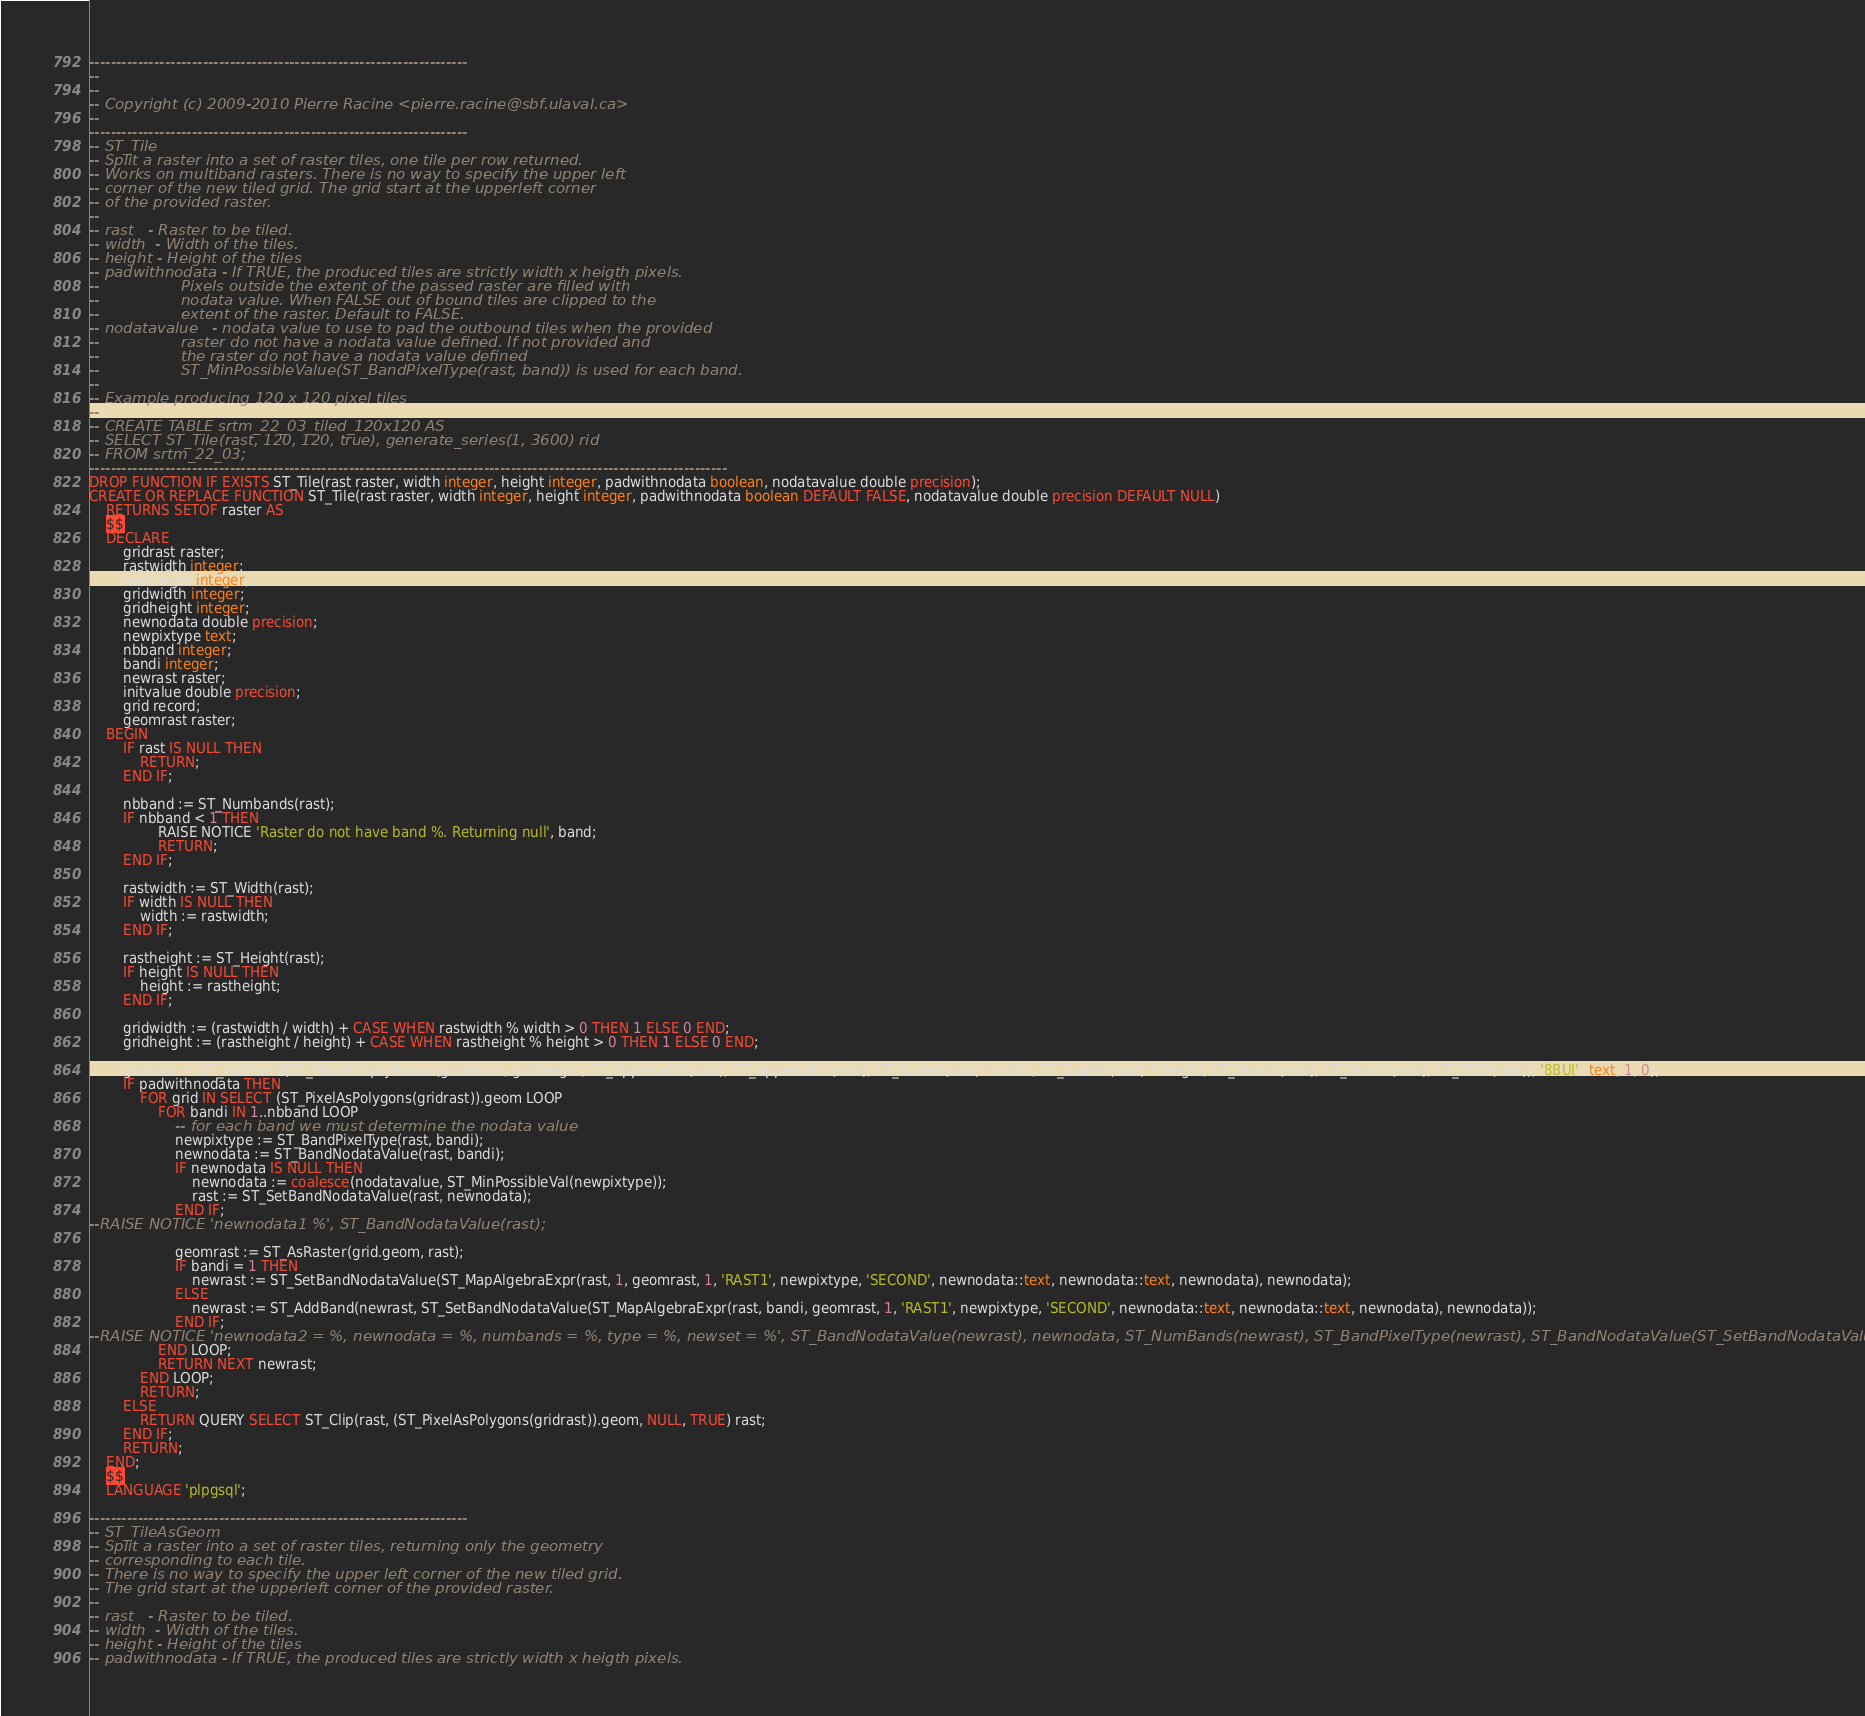<code> <loc_0><loc_0><loc_500><loc_500><_SQL_>----------------------------------------------------------------------
--
--
-- Copyright (c) 2009-2010 Pierre Racine <pierre.racine@sbf.ulaval.ca>
--
----------------------------------------------------------------------
-- ST_Tile
-- Split a raster into a set of raster tiles, one tile per row returned. 
-- Works on multiband rasters. There is no way to specify the upper left 
-- corner of the new tiled grid. The grid start at the upperleft corner 
-- of the provided raster.
--
-- rast   - Raster to be tiled.
-- width  - Width of the tiles.
-- height - Height of the tiles
-- padwithnodata - If TRUE, the produced tiles are strictly width x heigth pixels. 
--                 Pixels outside the extent of the passed raster are filled with 
--                 nodata value. When FALSE out of bound tiles are clipped to the 
--                 extent of the raster. Default to FALSE.
-- nodatavalue   - nodata value to use to pad the outbound tiles when the provided 
--                 raster do not have a nodata value defined. If not provided and 
--                 the raster do not have a nodata value defined 
--                 ST_MinPossibleValue(ST_BandPixelType(rast, band)) is used for each band.
--
-- Example producing 120 x 120 pixel tiles
--
-- CREATE TABLE srtm_22_03_tiled_120x120 AS
-- SELECT ST_Tile(rast, 120, 120, true), generate_series(1, 3600) rid
-- FROM srtm_22_03;
----------------------------------------------------------------------------------------------------------------------
DROP FUNCTION IF EXISTS ST_Tile(rast raster, width integer, height integer, padwithnodata boolean, nodatavalue double precision);
CREATE OR REPLACE FUNCTION ST_Tile(rast raster, width integer, height integer, padwithnodata boolean DEFAULT FALSE, nodatavalue double precision DEFAULT NULL) 
    RETURNS SETOF raster AS 
    $$
    DECLARE
        gridrast raster;
        rastwidth integer;
        rastheight integer;
        gridwidth integer;
        gridheight integer;
        newnodata double precision;
        newpixtype text;
        nbband integer;
        bandi integer;
        newrast raster;
        initvalue double precision;
        grid record;
        geomrast raster;
    BEGIN
        IF rast IS NULL THEN
            RETURN;
        END IF;
    
        nbband := ST_Numbands(rast);
        IF nbband < 1 THEN
                RAISE NOTICE 'Raster do not have band %. Returning null', band;
                RETURN;
        END IF;

        rastwidth := ST_Width(rast);
        IF width IS NULL THEN
            width := rastwidth;
        END IF;

        rastheight := ST_Height(rast);
        IF height IS NULL THEN
            height := rastheight;
        END IF;

        gridwidth := (rastwidth / width) + CASE WHEN rastwidth % width > 0 THEN 1 ELSE 0 END;
        gridheight := (rastheight / height) + CASE WHEN rastheight % height > 0 THEN 1 ELSE 0 END;

        gridrast := ST_AddBand(ST_MakeEmptyRaster(gridwidth, gridheight, ST_UpperLeftX(rast), ST_UpperLeftY(rast), ST_ScaleX(rast) * width, ST_ScaleY(rast) * height, ST_SkewX(rast), ST_SkewY(rast), ST_SRID(rast)), '8BUI'::text, 1, 0);
        IF padwithnodata THEN
            FOR grid IN SELECT (ST_PixelAsPolygons(gridrast)).geom LOOP
                FOR bandi IN 1..nbband LOOP
                    -- for each band we must determine the nodata value
                    newpixtype := ST_BandPixelType(rast, bandi);
                    newnodata := ST_BandNodataValue(rast, bandi);
                    IF newnodata IS NULL THEN
                        newnodata := coalesce(nodatavalue, ST_MinPossibleVal(newpixtype));
                        rast := ST_SetBandNodataValue(rast, newnodata);
                    END IF;
--RAISE NOTICE 'newnodata1 %', ST_BandNodataValue(rast);

                    geomrast := ST_AsRaster(grid.geom, rast);
                    IF bandi = 1 THEN
                        newrast := ST_SetBandNodataValue(ST_MapAlgebraExpr(rast, 1, geomrast, 1, 'RAST1', newpixtype, 'SECOND', newnodata::text, newnodata::text, newnodata), newnodata);
                    ELSE
                        newrast := ST_AddBand(newrast, ST_SetBandNodataValue(ST_MapAlgebraExpr(rast, bandi, geomrast, 1, 'RAST1', newpixtype, 'SECOND', newnodata::text, newnodata::text, newnodata), newnodata));
                    END IF;
--RAISE NOTICE 'newnodata2 = %, newnodata = %, numbands = %, type = %, newset = %', ST_BandNodataValue(newrast), newnodata, ST_NumBands(newrast), ST_BandPixelType(newrast), ST_BandNodataValue(ST_SetBandNodataValue(newrast, 1, -4));
                END LOOP;
                RETURN NEXT newrast;
            END LOOP;
            RETURN;
        ELSE
            RETURN QUERY SELECT ST_Clip(rast, (ST_PixelAsPolygons(gridrast)).geom, NULL, TRUE) rast;
        END IF;
        RETURN;
    END;
    $$
    LANGUAGE 'plpgsql';
    
----------------------------------------------------------------------
-- ST_TileAsGeom
-- Split a raster into a set of raster tiles, returning only the geometry 
-- corresponding to each tile. 
-- There is no way to specify the upper left corner of the new tiled grid. 
-- The grid start at the upperleft corner of the provided raster.
--
-- rast   - Raster to be tiled.
-- width  - Width of the tiles.
-- height - Height of the tiles
-- padwithnodata - If TRUE, the produced tiles are strictly width x heigth pixels. </code> 